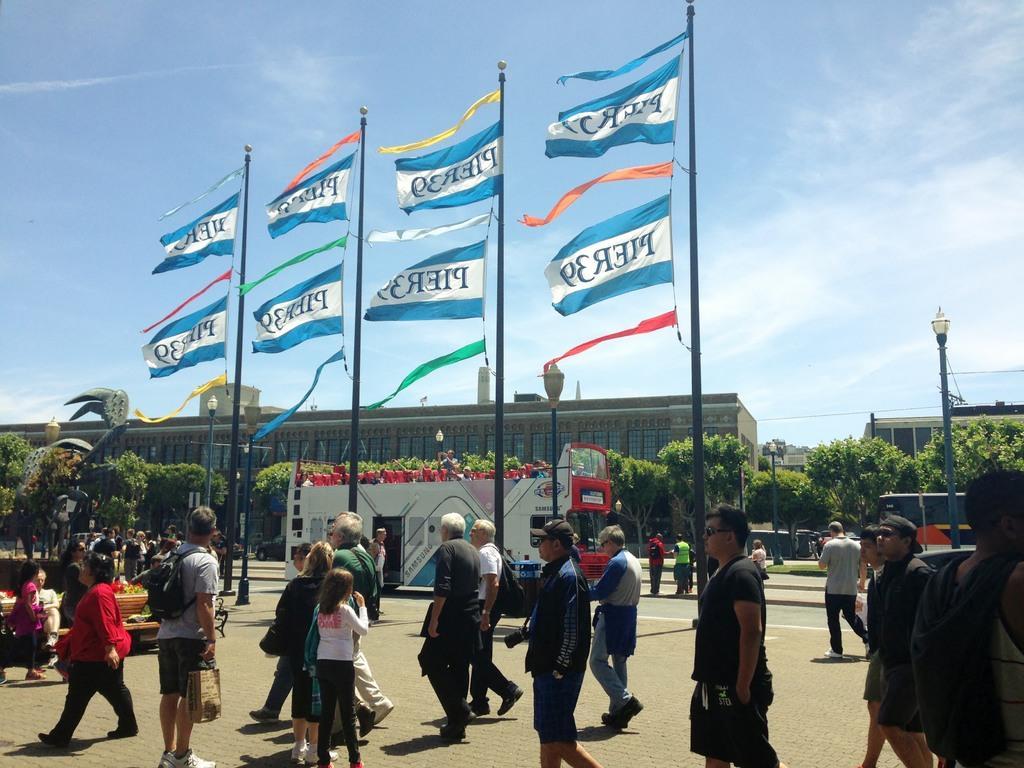Please provide a concise description of this image. In this picture, we can see there are groups of people walking on the path and a person is sitting on a bench. In front of the people there are poles with flags, lights, a vehicle parked on the road, buildings, trees and sky. 